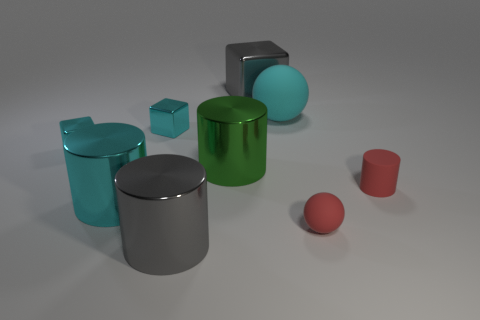Subtract all big shiny cubes. How many cubes are left? 2 Subtract 1 cylinders. How many cylinders are left? 3 Subtract all gray cylinders. How many cylinders are left? 3 Subtract all red cylinders. Subtract all purple spheres. How many cylinders are left? 3 Add 1 blue matte cylinders. How many objects exist? 10 Subtract all balls. How many objects are left? 7 Add 9 cyan rubber spheres. How many cyan rubber spheres are left? 10 Add 9 big purple objects. How many big purple objects exist? 9 Subtract 1 red balls. How many objects are left? 8 Subtract all tiny cubes. Subtract all cyan matte objects. How many objects are left? 6 